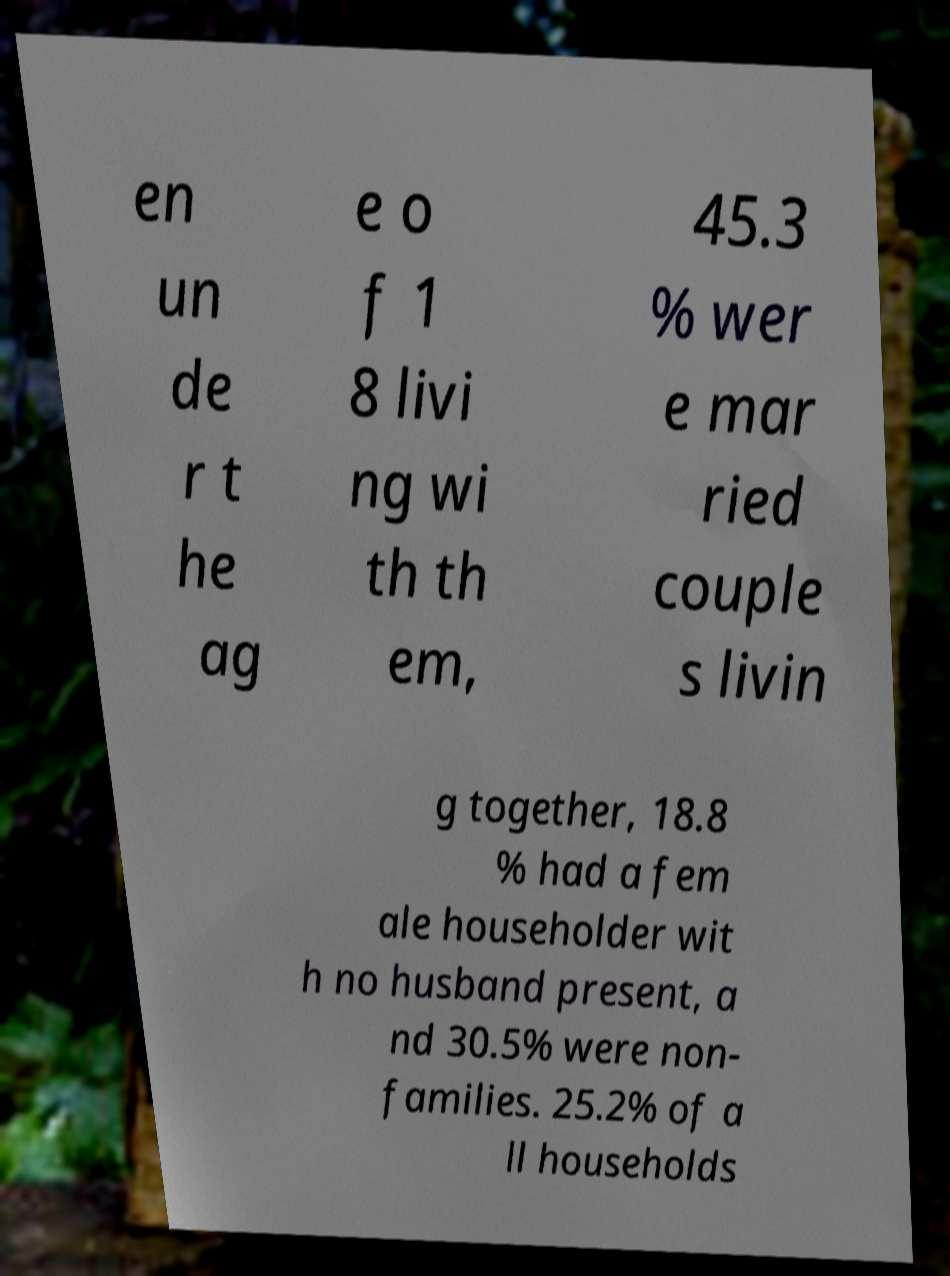Please identify and transcribe the text found in this image. en un de r t he ag e o f 1 8 livi ng wi th th em, 45.3 % wer e mar ried couple s livin g together, 18.8 % had a fem ale householder wit h no husband present, a nd 30.5% were non- families. 25.2% of a ll households 